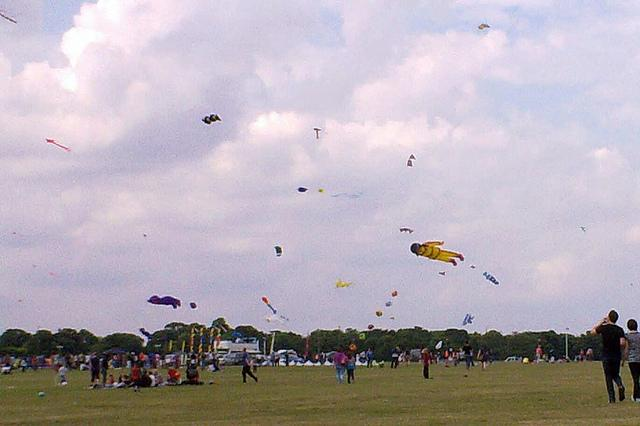What is the largest kite flying made to resemble?

Choices:
A) moth
B) cell phone
C) hummingbird
D) human human 